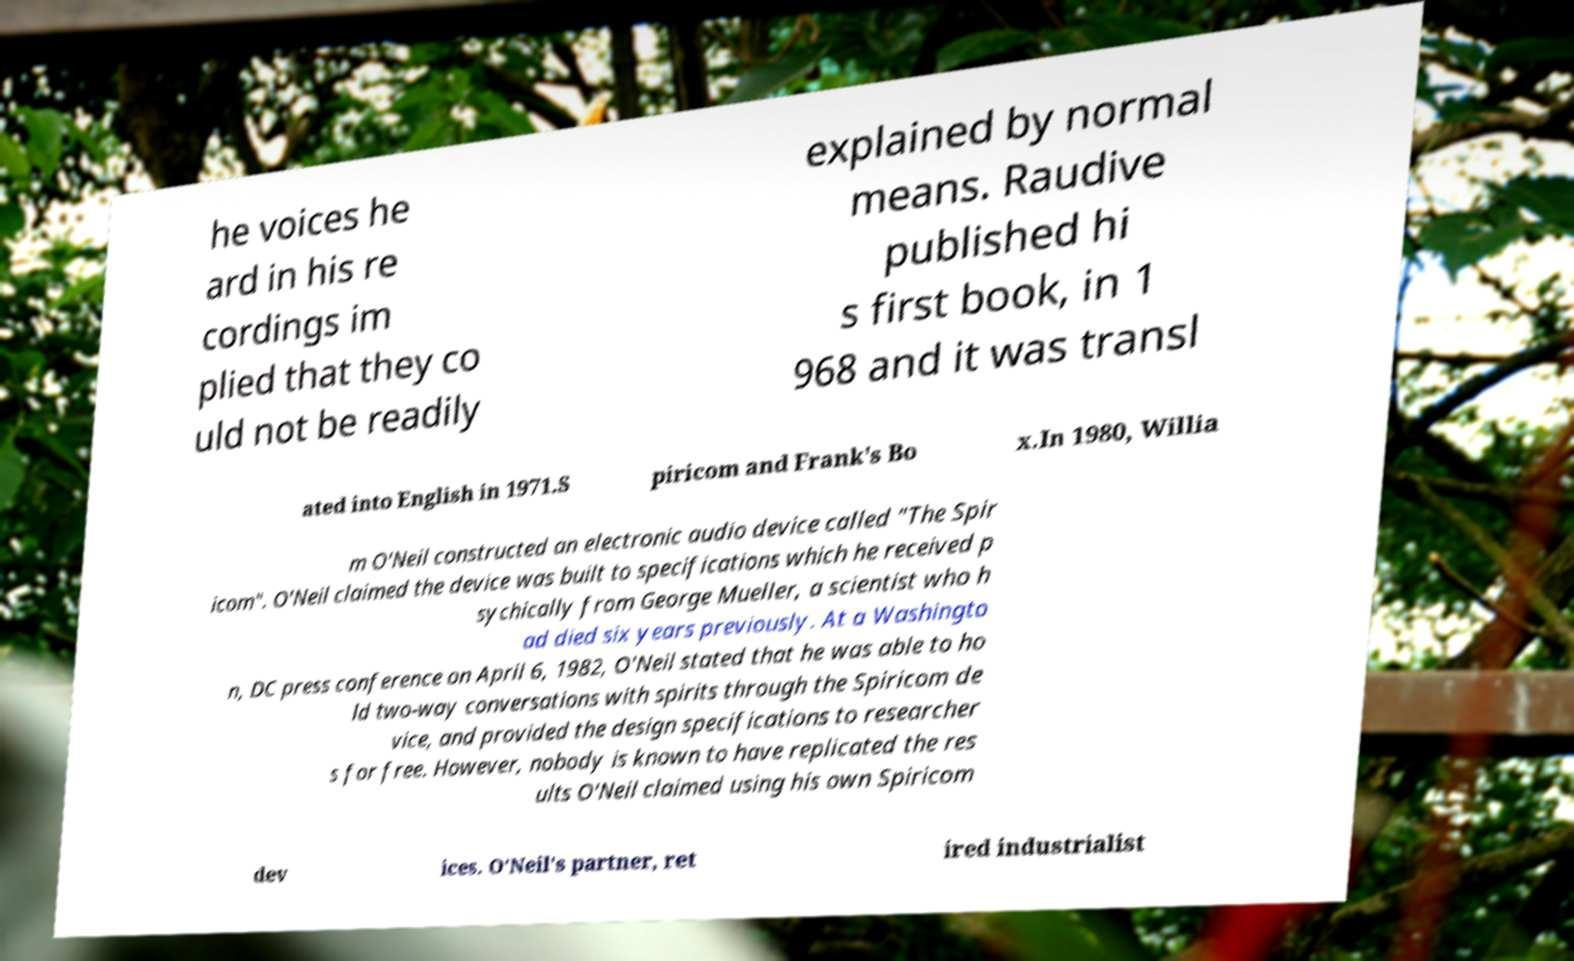Please identify and transcribe the text found in this image. he voices he ard in his re cordings im plied that they co uld not be readily explained by normal means. Raudive published hi s first book, in 1 968 and it was transl ated into English in 1971.S piricom and Frank's Bo x.In 1980, Willia m O'Neil constructed an electronic audio device called "The Spir icom". O'Neil claimed the device was built to specifications which he received p sychically from George Mueller, a scientist who h ad died six years previously. At a Washingto n, DC press conference on April 6, 1982, O'Neil stated that he was able to ho ld two-way conversations with spirits through the Spiricom de vice, and provided the design specifications to researcher s for free. However, nobody is known to have replicated the res ults O'Neil claimed using his own Spiricom dev ices. O'Neil's partner, ret ired industrialist 